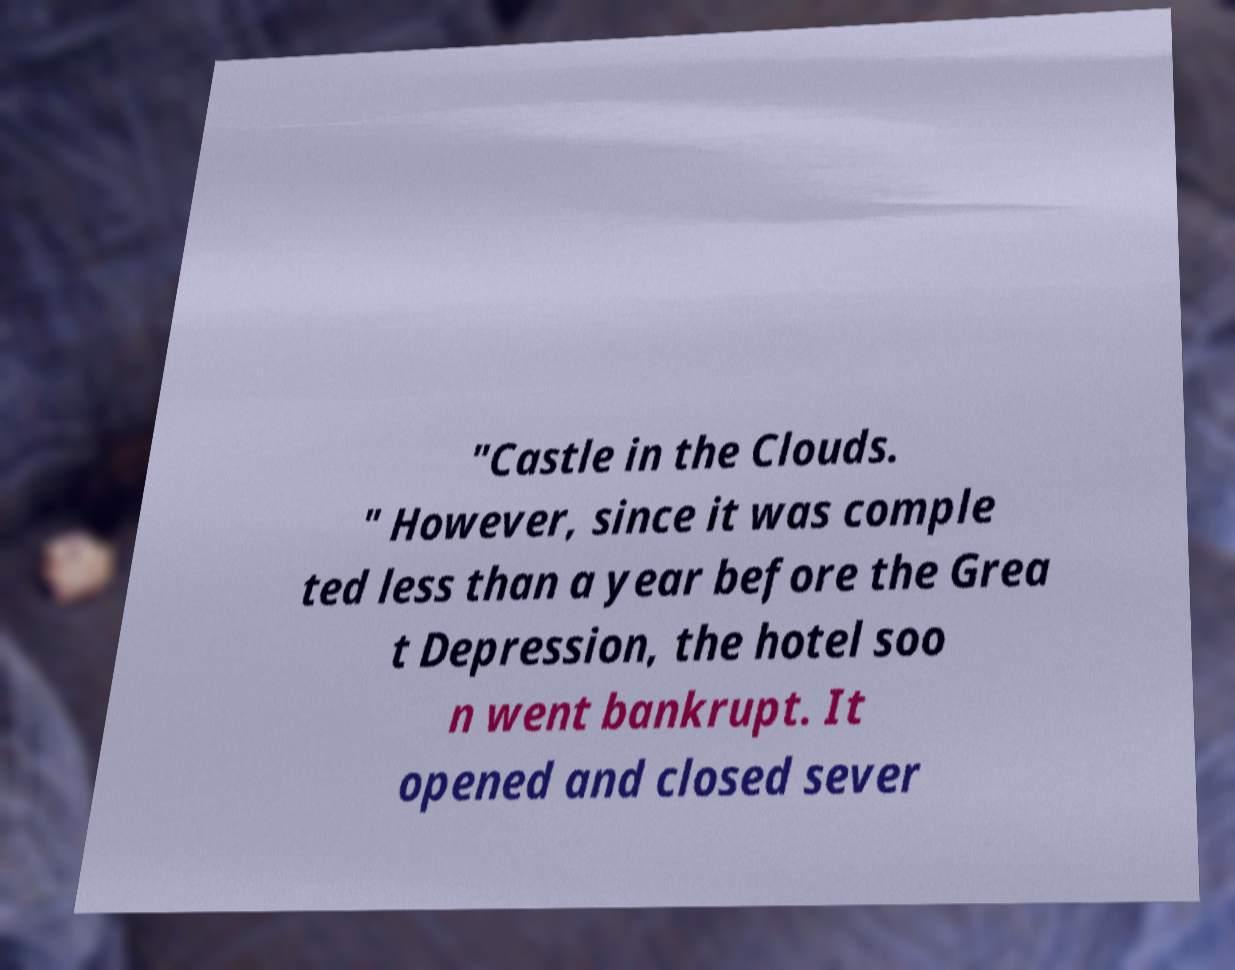Can you accurately transcribe the text from the provided image for me? "Castle in the Clouds. " However, since it was comple ted less than a year before the Grea t Depression, the hotel soo n went bankrupt. It opened and closed sever 